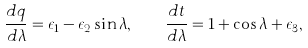Convert formula to latex. <formula><loc_0><loc_0><loc_500><loc_500>\frac { d q } { d \lambda } = \epsilon _ { 1 } - \epsilon _ { 2 } \sin \lambda , \quad \frac { d t } { d \lambda } = 1 + \cos \lambda + \epsilon _ { 3 } ,</formula> 